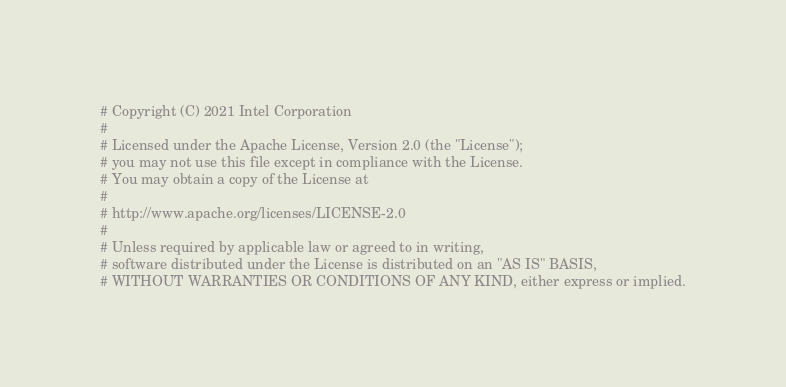<code> <loc_0><loc_0><loc_500><loc_500><_Python_># Copyright (C) 2021 Intel Corporation
#
# Licensed under the Apache License, Version 2.0 (the "License");
# you may not use this file except in compliance with the License.
# You may obtain a copy of the License at
#
# http://www.apache.org/licenses/LICENSE-2.0
#
# Unless required by applicable law or agreed to in writing,
# software distributed under the License is distributed on an "AS IS" BASIS,
# WITHOUT WARRANTIES OR CONDITIONS OF ANY KIND, either express or implied.</code> 